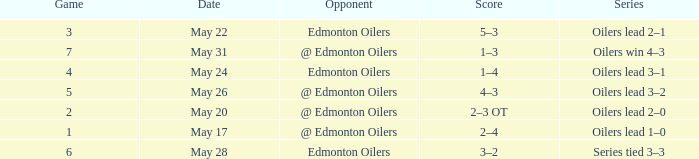Rival of edmonton oilers, and a trio of games is part of what series? Oilers lead 2–1. Parse the full table. {'header': ['Game', 'Date', 'Opponent', 'Score', 'Series'], 'rows': [['3', 'May 22', 'Edmonton Oilers', '5–3', 'Oilers lead 2–1'], ['7', 'May 31', '@ Edmonton Oilers', '1–3', 'Oilers win 4–3'], ['4', 'May 24', 'Edmonton Oilers', '1–4', 'Oilers lead 3–1'], ['5', 'May 26', '@ Edmonton Oilers', '4–3', 'Oilers lead 3–2'], ['2', 'May 20', '@ Edmonton Oilers', '2–3 OT', 'Oilers lead 2–0'], ['1', 'May 17', '@ Edmonton Oilers', '2–4', 'Oilers lead 1–0'], ['6', 'May 28', 'Edmonton Oilers', '3–2', 'Series tied 3–3']]} 